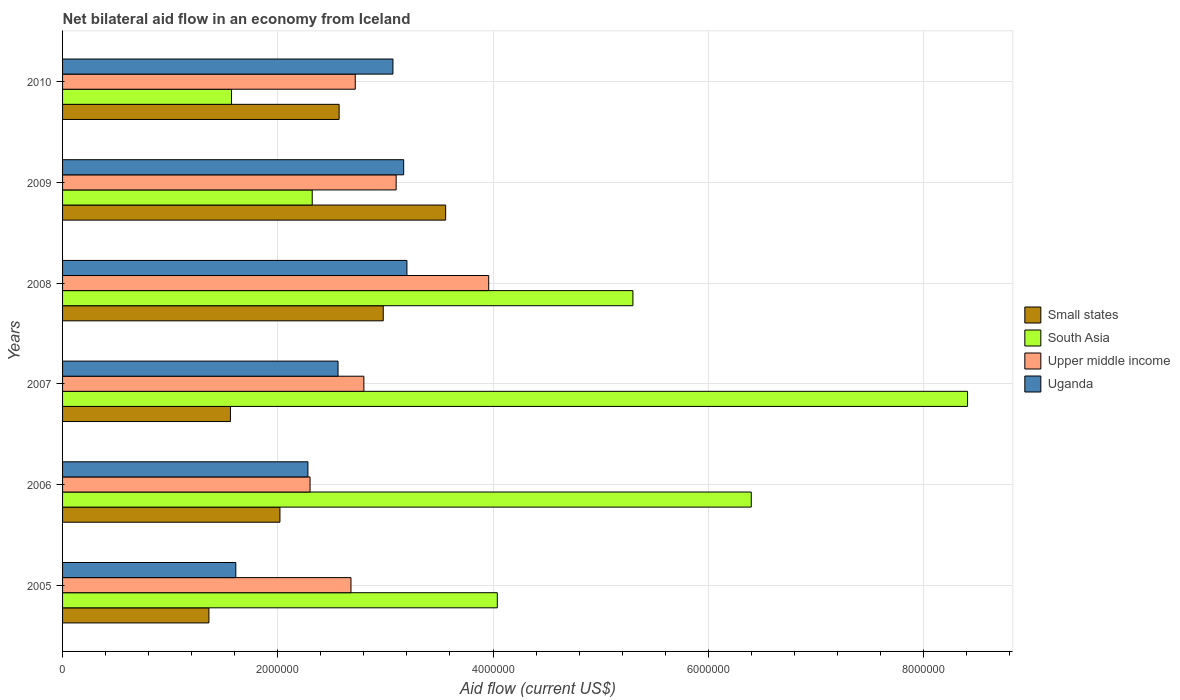How many groups of bars are there?
Offer a very short reply. 6. How many bars are there on the 4th tick from the top?
Make the answer very short. 4. How many bars are there on the 5th tick from the bottom?
Your answer should be compact. 4. What is the label of the 5th group of bars from the top?
Provide a short and direct response. 2006. In how many cases, is the number of bars for a given year not equal to the number of legend labels?
Make the answer very short. 0. What is the net bilateral aid flow in Upper middle income in 2010?
Offer a very short reply. 2.72e+06. Across all years, what is the maximum net bilateral aid flow in Uganda?
Provide a succinct answer. 3.20e+06. Across all years, what is the minimum net bilateral aid flow in Uganda?
Give a very brief answer. 1.61e+06. In which year was the net bilateral aid flow in Uganda maximum?
Make the answer very short. 2008. What is the total net bilateral aid flow in Upper middle income in the graph?
Provide a succinct answer. 1.76e+07. What is the difference between the net bilateral aid flow in South Asia in 2005 and that in 2009?
Provide a succinct answer. 1.72e+06. What is the difference between the net bilateral aid flow in South Asia in 2006 and the net bilateral aid flow in Upper middle income in 2007?
Your response must be concise. 3.60e+06. What is the average net bilateral aid flow in South Asia per year?
Keep it short and to the point. 4.67e+06. In the year 2007, what is the difference between the net bilateral aid flow in Small states and net bilateral aid flow in Upper middle income?
Your answer should be very brief. -1.24e+06. What is the ratio of the net bilateral aid flow in Small states in 2005 to that in 2008?
Ensure brevity in your answer.  0.46. Is the difference between the net bilateral aid flow in Small states in 2008 and 2009 greater than the difference between the net bilateral aid flow in Upper middle income in 2008 and 2009?
Your response must be concise. No. What is the difference between the highest and the second highest net bilateral aid flow in South Asia?
Keep it short and to the point. 2.01e+06. What is the difference between the highest and the lowest net bilateral aid flow in South Asia?
Make the answer very short. 6.84e+06. What does the 1st bar from the top in 2008 represents?
Offer a very short reply. Uganda. Is it the case that in every year, the sum of the net bilateral aid flow in South Asia and net bilateral aid flow in Upper middle income is greater than the net bilateral aid flow in Uganda?
Give a very brief answer. Yes. How many bars are there?
Offer a terse response. 24. How many years are there in the graph?
Provide a short and direct response. 6. What is the difference between two consecutive major ticks on the X-axis?
Keep it short and to the point. 2.00e+06. Where does the legend appear in the graph?
Keep it short and to the point. Center right. How many legend labels are there?
Your response must be concise. 4. How are the legend labels stacked?
Your answer should be very brief. Vertical. What is the title of the graph?
Give a very brief answer. Net bilateral aid flow in an economy from Iceland. What is the label or title of the X-axis?
Offer a terse response. Aid flow (current US$). What is the label or title of the Y-axis?
Provide a succinct answer. Years. What is the Aid flow (current US$) of Small states in 2005?
Make the answer very short. 1.36e+06. What is the Aid flow (current US$) of South Asia in 2005?
Your answer should be very brief. 4.04e+06. What is the Aid flow (current US$) of Upper middle income in 2005?
Provide a short and direct response. 2.68e+06. What is the Aid flow (current US$) in Uganda in 2005?
Keep it short and to the point. 1.61e+06. What is the Aid flow (current US$) of Small states in 2006?
Offer a terse response. 2.02e+06. What is the Aid flow (current US$) of South Asia in 2006?
Offer a terse response. 6.40e+06. What is the Aid flow (current US$) in Upper middle income in 2006?
Your answer should be compact. 2.30e+06. What is the Aid flow (current US$) of Uganda in 2006?
Your answer should be compact. 2.28e+06. What is the Aid flow (current US$) of Small states in 2007?
Your answer should be very brief. 1.56e+06. What is the Aid flow (current US$) of South Asia in 2007?
Your answer should be very brief. 8.41e+06. What is the Aid flow (current US$) in Upper middle income in 2007?
Offer a very short reply. 2.80e+06. What is the Aid flow (current US$) in Uganda in 2007?
Make the answer very short. 2.56e+06. What is the Aid flow (current US$) in Small states in 2008?
Provide a succinct answer. 2.98e+06. What is the Aid flow (current US$) of South Asia in 2008?
Your answer should be compact. 5.30e+06. What is the Aid flow (current US$) of Upper middle income in 2008?
Offer a terse response. 3.96e+06. What is the Aid flow (current US$) of Uganda in 2008?
Offer a terse response. 3.20e+06. What is the Aid flow (current US$) in Small states in 2009?
Your answer should be compact. 3.56e+06. What is the Aid flow (current US$) of South Asia in 2009?
Give a very brief answer. 2.32e+06. What is the Aid flow (current US$) in Upper middle income in 2009?
Your answer should be compact. 3.10e+06. What is the Aid flow (current US$) of Uganda in 2009?
Your answer should be very brief. 3.17e+06. What is the Aid flow (current US$) in Small states in 2010?
Offer a very short reply. 2.57e+06. What is the Aid flow (current US$) of South Asia in 2010?
Provide a short and direct response. 1.57e+06. What is the Aid flow (current US$) of Upper middle income in 2010?
Provide a short and direct response. 2.72e+06. What is the Aid flow (current US$) of Uganda in 2010?
Make the answer very short. 3.07e+06. Across all years, what is the maximum Aid flow (current US$) in Small states?
Provide a succinct answer. 3.56e+06. Across all years, what is the maximum Aid flow (current US$) in South Asia?
Make the answer very short. 8.41e+06. Across all years, what is the maximum Aid flow (current US$) of Upper middle income?
Ensure brevity in your answer.  3.96e+06. Across all years, what is the maximum Aid flow (current US$) of Uganda?
Give a very brief answer. 3.20e+06. Across all years, what is the minimum Aid flow (current US$) in Small states?
Your response must be concise. 1.36e+06. Across all years, what is the minimum Aid flow (current US$) in South Asia?
Your answer should be compact. 1.57e+06. Across all years, what is the minimum Aid flow (current US$) of Upper middle income?
Make the answer very short. 2.30e+06. Across all years, what is the minimum Aid flow (current US$) in Uganda?
Your response must be concise. 1.61e+06. What is the total Aid flow (current US$) in Small states in the graph?
Ensure brevity in your answer.  1.40e+07. What is the total Aid flow (current US$) in South Asia in the graph?
Provide a succinct answer. 2.80e+07. What is the total Aid flow (current US$) of Upper middle income in the graph?
Ensure brevity in your answer.  1.76e+07. What is the total Aid flow (current US$) in Uganda in the graph?
Give a very brief answer. 1.59e+07. What is the difference between the Aid flow (current US$) in Small states in 2005 and that in 2006?
Offer a terse response. -6.60e+05. What is the difference between the Aid flow (current US$) in South Asia in 2005 and that in 2006?
Ensure brevity in your answer.  -2.36e+06. What is the difference between the Aid flow (current US$) in Upper middle income in 2005 and that in 2006?
Your answer should be compact. 3.80e+05. What is the difference between the Aid flow (current US$) in Uganda in 2005 and that in 2006?
Offer a very short reply. -6.70e+05. What is the difference between the Aid flow (current US$) of South Asia in 2005 and that in 2007?
Keep it short and to the point. -4.37e+06. What is the difference between the Aid flow (current US$) of Uganda in 2005 and that in 2007?
Make the answer very short. -9.50e+05. What is the difference between the Aid flow (current US$) of Small states in 2005 and that in 2008?
Ensure brevity in your answer.  -1.62e+06. What is the difference between the Aid flow (current US$) in South Asia in 2005 and that in 2008?
Keep it short and to the point. -1.26e+06. What is the difference between the Aid flow (current US$) of Upper middle income in 2005 and that in 2008?
Offer a very short reply. -1.28e+06. What is the difference between the Aid flow (current US$) in Uganda in 2005 and that in 2008?
Ensure brevity in your answer.  -1.59e+06. What is the difference between the Aid flow (current US$) in Small states in 2005 and that in 2009?
Keep it short and to the point. -2.20e+06. What is the difference between the Aid flow (current US$) of South Asia in 2005 and that in 2009?
Provide a short and direct response. 1.72e+06. What is the difference between the Aid flow (current US$) in Upper middle income in 2005 and that in 2009?
Ensure brevity in your answer.  -4.20e+05. What is the difference between the Aid flow (current US$) in Uganda in 2005 and that in 2009?
Your answer should be very brief. -1.56e+06. What is the difference between the Aid flow (current US$) of Small states in 2005 and that in 2010?
Keep it short and to the point. -1.21e+06. What is the difference between the Aid flow (current US$) in South Asia in 2005 and that in 2010?
Your answer should be compact. 2.47e+06. What is the difference between the Aid flow (current US$) in Uganda in 2005 and that in 2010?
Make the answer very short. -1.46e+06. What is the difference between the Aid flow (current US$) of Small states in 2006 and that in 2007?
Give a very brief answer. 4.60e+05. What is the difference between the Aid flow (current US$) in South Asia in 2006 and that in 2007?
Offer a very short reply. -2.01e+06. What is the difference between the Aid flow (current US$) of Upper middle income in 2006 and that in 2007?
Your response must be concise. -5.00e+05. What is the difference between the Aid flow (current US$) of Uganda in 2006 and that in 2007?
Keep it short and to the point. -2.80e+05. What is the difference between the Aid flow (current US$) in Small states in 2006 and that in 2008?
Your response must be concise. -9.60e+05. What is the difference between the Aid flow (current US$) in South Asia in 2006 and that in 2008?
Your answer should be compact. 1.10e+06. What is the difference between the Aid flow (current US$) in Upper middle income in 2006 and that in 2008?
Your answer should be very brief. -1.66e+06. What is the difference between the Aid flow (current US$) in Uganda in 2006 and that in 2008?
Provide a succinct answer. -9.20e+05. What is the difference between the Aid flow (current US$) in Small states in 2006 and that in 2009?
Your answer should be very brief. -1.54e+06. What is the difference between the Aid flow (current US$) in South Asia in 2006 and that in 2009?
Provide a short and direct response. 4.08e+06. What is the difference between the Aid flow (current US$) of Upper middle income in 2006 and that in 2009?
Offer a very short reply. -8.00e+05. What is the difference between the Aid flow (current US$) of Uganda in 2006 and that in 2009?
Your answer should be compact. -8.90e+05. What is the difference between the Aid flow (current US$) of Small states in 2006 and that in 2010?
Provide a short and direct response. -5.50e+05. What is the difference between the Aid flow (current US$) in South Asia in 2006 and that in 2010?
Your response must be concise. 4.83e+06. What is the difference between the Aid flow (current US$) of Upper middle income in 2006 and that in 2010?
Provide a succinct answer. -4.20e+05. What is the difference between the Aid flow (current US$) of Uganda in 2006 and that in 2010?
Provide a succinct answer. -7.90e+05. What is the difference between the Aid flow (current US$) in Small states in 2007 and that in 2008?
Ensure brevity in your answer.  -1.42e+06. What is the difference between the Aid flow (current US$) of South Asia in 2007 and that in 2008?
Your answer should be compact. 3.11e+06. What is the difference between the Aid flow (current US$) in Upper middle income in 2007 and that in 2008?
Your answer should be compact. -1.16e+06. What is the difference between the Aid flow (current US$) in Uganda in 2007 and that in 2008?
Give a very brief answer. -6.40e+05. What is the difference between the Aid flow (current US$) in South Asia in 2007 and that in 2009?
Your answer should be compact. 6.09e+06. What is the difference between the Aid flow (current US$) in Upper middle income in 2007 and that in 2009?
Your answer should be compact. -3.00e+05. What is the difference between the Aid flow (current US$) in Uganda in 2007 and that in 2009?
Keep it short and to the point. -6.10e+05. What is the difference between the Aid flow (current US$) of Small states in 2007 and that in 2010?
Ensure brevity in your answer.  -1.01e+06. What is the difference between the Aid flow (current US$) in South Asia in 2007 and that in 2010?
Ensure brevity in your answer.  6.84e+06. What is the difference between the Aid flow (current US$) in Upper middle income in 2007 and that in 2010?
Offer a terse response. 8.00e+04. What is the difference between the Aid flow (current US$) in Uganda in 2007 and that in 2010?
Make the answer very short. -5.10e+05. What is the difference between the Aid flow (current US$) in Small states in 2008 and that in 2009?
Give a very brief answer. -5.80e+05. What is the difference between the Aid flow (current US$) of South Asia in 2008 and that in 2009?
Your answer should be compact. 2.98e+06. What is the difference between the Aid flow (current US$) in Upper middle income in 2008 and that in 2009?
Give a very brief answer. 8.60e+05. What is the difference between the Aid flow (current US$) in Small states in 2008 and that in 2010?
Offer a terse response. 4.10e+05. What is the difference between the Aid flow (current US$) of South Asia in 2008 and that in 2010?
Offer a terse response. 3.73e+06. What is the difference between the Aid flow (current US$) in Upper middle income in 2008 and that in 2010?
Make the answer very short. 1.24e+06. What is the difference between the Aid flow (current US$) in Small states in 2009 and that in 2010?
Provide a short and direct response. 9.90e+05. What is the difference between the Aid flow (current US$) in South Asia in 2009 and that in 2010?
Offer a very short reply. 7.50e+05. What is the difference between the Aid flow (current US$) of Small states in 2005 and the Aid flow (current US$) of South Asia in 2006?
Give a very brief answer. -5.04e+06. What is the difference between the Aid flow (current US$) in Small states in 2005 and the Aid flow (current US$) in Upper middle income in 2006?
Keep it short and to the point. -9.40e+05. What is the difference between the Aid flow (current US$) of Small states in 2005 and the Aid flow (current US$) of Uganda in 2006?
Your response must be concise. -9.20e+05. What is the difference between the Aid flow (current US$) of South Asia in 2005 and the Aid flow (current US$) of Upper middle income in 2006?
Your answer should be compact. 1.74e+06. What is the difference between the Aid flow (current US$) of South Asia in 2005 and the Aid flow (current US$) of Uganda in 2006?
Give a very brief answer. 1.76e+06. What is the difference between the Aid flow (current US$) in Upper middle income in 2005 and the Aid flow (current US$) in Uganda in 2006?
Make the answer very short. 4.00e+05. What is the difference between the Aid flow (current US$) in Small states in 2005 and the Aid flow (current US$) in South Asia in 2007?
Ensure brevity in your answer.  -7.05e+06. What is the difference between the Aid flow (current US$) in Small states in 2005 and the Aid flow (current US$) in Upper middle income in 2007?
Make the answer very short. -1.44e+06. What is the difference between the Aid flow (current US$) of Small states in 2005 and the Aid flow (current US$) of Uganda in 2007?
Your answer should be compact. -1.20e+06. What is the difference between the Aid flow (current US$) of South Asia in 2005 and the Aid flow (current US$) of Upper middle income in 2007?
Keep it short and to the point. 1.24e+06. What is the difference between the Aid flow (current US$) in South Asia in 2005 and the Aid flow (current US$) in Uganda in 2007?
Ensure brevity in your answer.  1.48e+06. What is the difference between the Aid flow (current US$) in Upper middle income in 2005 and the Aid flow (current US$) in Uganda in 2007?
Your answer should be very brief. 1.20e+05. What is the difference between the Aid flow (current US$) in Small states in 2005 and the Aid flow (current US$) in South Asia in 2008?
Your response must be concise. -3.94e+06. What is the difference between the Aid flow (current US$) of Small states in 2005 and the Aid flow (current US$) of Upper middle income in 2008?
Ensure brevity in your answer.  -2.60e+06. What is the difference between the Aid flow (current US$) of Small states in 2005 and the Aid flow (current US$) of Uganda in 2008?
Make the answer very short. -1.84e+06. What is the difference between the Aid flow (current US$) in South Asia in 2005 and the Aid flow (current US$) in Uganda in 2008?
Your response must be concise. 8.40e+05. What is the difference between the Aid flow (current US$) of Upper middle income in 2005 and the Aid flow (current US$) of Uganda in 2008?
Your response must be concise. -5.20e+05. What is the difference between the Aid flow (current US$) in Small states in 2005 and the Aid flow (current US$) in South Asia in 2009?
Provide a short and direct response. -9.60e+05. What is the difference between the Aid flow (current US$) of Small states in 2005 and the Aid flow (current US$) of Upper middle income in 2009?
Make the answer very short. -1.74e+06. What is the difference between the Aid flow (current US$) of Small states in 2005 and the Aid flow (current US$) of Uganda in 2009?
Provide a short and direct response. -1.81e+06. What is the difference between the Aid flow (current US$) in South Asia in 2005 and the Aid flow (current US$) in Upper middle income in 2009?
Your answer should be very brief. 9.40e+05. What is the difference between the Aid flow (current US$) of South Asia in 2005 and the Aid flow (current US$) of Uganda in 2009?
Ensure brevity in your answer.  8.70e+05. What is the difference between the Aid flow (current US$) of Upper middle income in 2005 and the Aid flow (current US$) of Uganda in 2009?
Ensure brevity in your answer.  -4.90e+05. What is the difference between the Aid flow (current US$) of Small states in 2005 and the Aid flow (current US$) of Upper middle income in 2010?
Your response must be concise. -1.36e+06. What is the difference between the Aid flow (current US$) of Small states in 2005 and the Aid flow (current US$) of Uganda in 2010?
Give a very brief answer. -1.71e+06. What is the difference between the Aid flow (current US$) of South Asia in 2005 and the Aid flow (current US$) of Upper middle income in 2010?
Offer a very short reply. 1.32e+06. What is the difference between the Aid flow (current US$) of South Asia in 2005 and the Aid flow (current US$) of Uganda in 2010?
Give a very brief answer. 9.70e+05. What is the difference between the Aid flow (current US$) in Upper middle income in 2005 and the Aid flow (current US$) in Uganda in 2010?
Offer a very short reply. -3.90e+05. What is the difference between the Aid flow (current US$) of Small states in 2006 and the Aid flow (current US$) of South Asia in 2007?
Offer a terse response. -6.39e+06. What is the difference between the Aid flow (current US$) of Small states in 2006 and the Aid flow (current US$) of Upper middle income in 2007?
Provide a succinct answer. -7.80e+05. What is the difference between the Aid flow (current US$) in Small states in 2006 and the Aid flow (current US$) in Uganda in 2007?
Your response must be concise. -5.40e+05. What is the difference between the Aid flow (current US$) of South Asia in 2006 and the Aid flow (current US$) of Upper middle income in 2007?
Your response must be concise. 3.60e+06. What is the difference between the Aid flow (current US$) in South Asia in 2006 and the Aid flow (current US$) in Uganda in 2007?
Provide a short and direct response. 3.84e+06. What is the difference between the Aid flow (current US$) in Small states in 2006 and the Aid flow (current US$) in South Asia in 2008?
Your answer should be very brief. -3.28e+06. What is the difference between the Aid flow (current US$) in Small states in 2006 and the Aid flow (current US$) in Upper middle income in 2008?
Ensure brevity in your answer.  -1.94e+06. What is the difference between the Aid flow (current US$) of Small states in 2006 and the Aid flow (current US$) of Uganda in 2008?
Ensure brevity in your answer.  -1.18e+06. What is the difference between the Aid flow (current US$) of South Asia in 2006 and the Aid flow (current US$) of Upper middle income in 2008?
Provide a succinct answer. 2.44e+06. What is the difference between the Aid flow (current US$) of South Asia in 2006 and the Aid flow (current US$) of Uganda in 2008?
Offer a terse response. 3.20e+06. What is the difference between the Aid flow (current US$) in Upper middle income in 2006 and the Aid flow (current US$) in Uganda in 2008?
Your response must be concise. -9.00e+05. What is the difference between the Aid flow (current US$) in Small states in 2006 and the Aid flow (current US$) in Upper middle income in 2009?
Your answer should be compact. -1.08e+06. What is the difference between the Aid flow (current US$) of Small states in 2006 and the Aid flow (current US$) of Uganda in 2009?
Give a very brief answer. -1.15e+06. What is the difference between the Aid flow (current US$) of South Asia in 2006 and the Aid flow (current US$) of Upper middle income in 2009?
Your answer should be compact. 3.30e+06. What is the difference between the Aid flow (current US$) in South Asia in 2006 and the Aid flow (current US$) in Uganda in 2009?
Give a very brief answer. 3.23e+06. What is the difference between the Aid flow (current US$) in Upper middle income in 2006 and the Aid flow (current US$) in Uganda in 2009?
Ensure brevity in your answer.  -8.70e+05. What is the difference between the Aid flow (current US$) of Small states in 2006 and the Aid flow (current US$) of Upper middle income in 2010?
Ensure brevity in your answer.  -7.00e+05. What is the difference between the Aid flow (current US$) of Small states in 2006 and the Aid flow (current US$) of Uganda in 2010?
Provide a short and direct response. -1.05e+06. What is the difference between the Aid flow (current US$) in South Asia in 2006 and the Aid flow (current US$) in Upper middle income in 2010?
Offer a terse response. 3.68e+06. What is the difference between the Aid flow (current US$) of South Asia in 2006 and the Aid flow (current US$) of Uganda in 2010?
Give a very brief answer. 3.33e+06. What is the difference between the Aid flow (current US$) of Upper middle income in 2006 and the Aid flow (current US$) of Uganda in 2010?
Make the answer very short. -7.70e+05. What is the difference between the Aid flow (current US$) of Small states in 2007 and the Aid flow (current US$) of South Asia in 2008?
Provide a succinct answer. -3.74e+06. What is the difference between the Aid flow (current US$) of Small states in 2007 and the Aid flow (current US$) of Upper middle income in 2008?
Make the answer very short. -2.40e+06. What is the difference between the Aid flow (current US$) in Small states in 2007 and the Aid flow (current US$) in Uganda in 2008?
Make the answer very short. -1.64e+06. What is the difference between the Aid flow (current US$) of South Asia in 2007 and the Aid flow (current US$) of Upper middle income in 2008?
Provide a short and direct response. 4.45e+06. What is the difference between the Aid flow (current US$) of South Asia in 2007 and the Aid flow (current US$) of Uganda in 2008?
Your answer should be very brief. 5.21e+06. What is the difference between the Aid flow (current US$) of Upper middle income in 2007 and the Aid flow (current US$) of Uganda in 2008?
Your answer should be very brief. -4.00e+05. What is the difference between the Aid flow (current US$) in Small states in 2007 and the Aid flow (current US$) in South Asia in 2009?
Give a very brief answer. -7.60e+05. What is the difference between the Aid flow (current US$) of Small states in 2007 and the Aid flow (current US$) of Upper middle income in 2009?
Give a very brief answer. -1.54e+06. What is the difference between the Aid flow (current US$) in Small states in 2007 and the Aid flow (current US$) in Uganda in 2009?
Give a very brief answer. -1.61e+06. What is the difference between the Aid flow (current US$) in South Asia in 2007 and the Aid flow (current US$) in Upper middle income in 2009?
Ensure brevity in your answer.  5.31e+06. What is the difference between the Aid flow (current US$) in South Asia in 2007 and the Aid flow (current US$) in Uganda in 2009?
Provide a succinct answer. 5.24e+06. What is the difference between the Aid flow (current US$) of Upper middle income in 2007 and the Aid flow (current US$) of Uganda in 2009?
Give a very brief answer. -3.70e+05. What is the difference between the Aid flow (current US$) in Small states in 2007 and the Aid flow (current US$) in Upper middle income in 2010?
Keep it short and to the point. -1.16e+06. What is the difference between the Aid flow (current US$) in Small states in 2007 and the Aid flow (current US$) in Uganda in 2010?
Give a very brief answer. -1.51e+06. What is the difference between the Aid flow (current US$) in South Asia in 2007 and the Aid flow (current US$) in Upper middle income in 2010?
Keep it short and to the point. 5.69e+06. What is the difference between the Aid flow (current US$) in South Asia in 2007 and the Aid flow (current US$) in Uganda in 2010?
Your answer should be compact. 5.34e+06. What is the difference between the Aid flow (current US$) in Upper middle income in 2007 and the Aid flow (current US$) in Uganda in 2010?
Ensure brevity in your answer.  -2.70e+05. What is the difference between the Aid flow (current US$) in Small states in 2008 and the Aid flow (current US$) in South Asia in 2009?
Your response must be concise. 6.60e+05. What is the difference between the Aid flow (current US$) of Small states in 2008 and the Aid flow (current US$) of Upper middle income in 2009?
Your response must be concise. -1.20e+05. What is the difference between the Aid flow (current US$) in South Asia in 2008 and the Aid flow (current US$) in Upper middle income in 2009?
Offer a terse response. 2.20e+06. What is the difference between the Aid flow (current US$) in South Asia in 2008 and the Aid flow (current US$) in Uganda in 2009?
Ensure brevity in your answer.  2.13e+06. What is the difference between the Aid flow (current US$) of Upper middle income in 2008 and the Aid flow (current US$) of Uganda in 2009?
Offer a very short reply. 7.90e+05. What is the difference between the Aid flow (current US$) of Small states in 2008 and the Aid flow (current US$) of South Asia in 2010?
Give a very brief answer. 1.41e+06. What is the difference between the Aid flow (current US$) of Small states in 2008 and the Aid flow (current US$) of Uganda in 2010?
Offer a terse response. -9.00e+04. What is the difference between the Aid flow (current US$) in South Asia in 2008 and the Aid flow (current US$) in Upper middle income in 2010?
Provide a succinct answer. 2.58e+06. What is the difference between the Aid flow (current US$) of South Asia in 2008 and the Aid flow (current US$) of Uganda in 2010?
Your response must be concise. 2.23e+06. What is the difference between the Aid flow (current US$) in Upper middle income in 2008 and the Aid flow (current US$) in Uganda in 2010?
Offer a terse response. 8.90e+05. What is the difference between the Aid flow (current US$) in Small states in 2009 and the Aid flow (current US$) in South Asia in 2010?
Provide a short and direct response. 1.99e+06. What is the difference between the Aid flow (current US$) in Small states in 2009 and the Aid flow (current US$) in Upper middle income in 2010?
Keep it short and to the point. 8.40e+05. What is the difference between the Aid flow (current US$) of Small states in 2009 and the Aid flow (current US$) of Uganda in 2010?
Give a very brief answer. 4.90e+05. What is the difference between the Aid flow (current US$) in South Asia in 2009 and the Aid flow (current US$) in Upper middle income in 2010?
Your answer should be compact. -4.00e+05. What is the difference between the Aid flow (current US$) in South Asia in 2009 and the Aid flow (current US$) in Uganda in 2010?
Ensure brevity in your answer.  -7.50e+05. What is the average Aid flow (current US$) in Small states per year?
Make the answer very short. 2.34e+06. What is the average Aid flow (current US$) in South Asia per year?
Offer a terse response. 4.67e+06. What is the average Aid flow (current US$) in Upper middle income per year?
Keep it short and to the point. 2.93e+06. What is the average Aid flow (current US$) in Uganda per year?
Give a very brief answer. 2.65e+06. In the year 2005, what is the difference between the Aid flow (current US$) in Small states and Aid flow (current US$) in South Asia?
Provide a short and direct response. -2.68e+06. In the year 2005, what is the difference between the Aid flow (current US$) in Small states and Aid flow (current US$) in Upper middle income?
Your answer should be very brief. -1.32e+06. In the year 2005, what is the difference between the Aid flow (current US$) of Small states and Aid flow (current US$) of Uganda?
Your response must be concise. -2.50e+05. In the year 2005, what is the difference between the Aid flow (current US$) in South Asia and Aid flow (current US$) in Upper middle income?
Provide a succinct answer. 1.36e+06. In the year 2005, what is the difference between the Aid flow (current US$) in South Asia and Aid flow (current US$) in Uganda?
Offer a very short reply. 2.43e+06. In the year 2005, what is the difference between the Aid flow (current US$) in Upper middle income and Aid flow (current US$) in Uganda?
Provide a short and direct response. 1.07e+06. In the year 2006, what is the difference between the Aid flow (current US$) of Small states and Aid flow (current US$) of South Asia?
Offer a very short reply. -4.38e+06. In the year 2006, what is the difference between the Aid flow (current US$) of Small states and Aid flow (current US$) of Upper middle income?
Make the answer very short. -2.80e+05. In the year 2006, what is the difference between the Aid flow (current US$) of Small states and Aid flow (current US$) of Uganda?
Give a very brief answer. -2.60e+05. In the year 2006, what is the difference between the Aid flow (current US$) of South Asia and Aid flow (current US$) of Upper middle income?
Your answer should be compact. 4.10e+06. In the year 2006, what is the difference between the Aid flow (current US$) in South Asia and Aid flow (current US$) in Uganda?
Provide a short and direct response. 4.12e+06. In the year 2006, what is the difference between the Aid flow (current US$) in Upper middle income and Aid flow (current US$) in Uganda?
Your answer should be very brief. 2.00e+04. In the year 2007, what is the difference between the Aid flow (current US$) of Small states and Aid flow (current US$) of South Asia?
Provide a succinct answer. -6.85e+06. In the year 2007, what is the difference between the Aid flow (current US$) of Small states and Aid flow (current US$) of Upper middle income?
Make the answer very short. -1.24e+06. In the year 2007, what is the difference between the Aid flow (current US$) of Small states and Aid flow (current US$) of Uganda?
Provide a succinct answer. -1.00e+06. In the year 2007, what is the difference between the Aid flow (current US$) of South Asia and Aid flow (current US$) of Upper middle income?
Your answer should be compact. 5.61e+06. In the year 2007, what is the difference between the Aid flow (current US$) of South Asia and Aid flow (current US$) of Uganda?
Ensure brevity in your answer.  5.85e+06. In the year 2007, what is the difference between the Aid flow (current US$) in Upper middle income and Aid flow (current US$) in Uganda?
Provide a succinct answer. 2.40e+05. In the year 2008, what is the difference between the Aid flow (current US$) in Small states and Aid flow (current US$) in South Asia?
Your answer should be very brief. -2.32e+06. In the year 2008, what is the difference between the Aid flow (current US$) of Small states and Aid flow (current US$) of Upper middle income?
Provide a short and direct response. -9.80e+05. In the year 2008, what is the difference between the Aid flow (current US$) of Small states and Aid flow (current US$) of Uganda?
Ensure brevity in your answer.  -2.20e+05. In the year 2008, what is the difference between the Aid flow (current US$) of South Asia and Aid flow (current US$) of Upper middle income?
Give a very brief answer. 1.34e+06. In the year 2008, what is the difference between the Aid flow (current US$) of South Asia and Aid flow (current US$) of Uganda?
Provide a short and direct response. 2.10e+06. In the year 2008, what is the difference between the Aid flow (current US$) of Upper middle income and Aid flow (current US$) of Uganda?
Make the answer very short. 7.60e+05. In the year 2009, what is the difference between the Aid flow (current US$) of Small states and Aid flow (current US$) of South Asia?
Offer a terse response. 1.24e+06. In the year 2009, what is the difference between the Aid flow (current US$) of Small states and Aid flow (current US$) of Upper middle income?
Offer a very short reply. 4.60e+05. In the year 2009, what is the difference between the Aid flow (current US$) in Small states and Aid flow (current US$) in Uganda?
Provide a succinct answer. 3.90e+05. In the year 2009, what is the difference between the Aid flow (current US$) of South Asia and Aid flow (current US$) of Upper middle income?
Provide a short and direct response. -7.80e+05. In the year 2009, what is the difference between the Aid flow (current US$) in South Asia and Aid flow (current US$) in Uganda?
Your answer should be very brief. -8.50e+05. In the year 2010, what is the difference between the Aid flow (current US$) in Small states and Aid flow (current US$) in South Asia?
Give a very brief answer. 1.00e+06. In the year 2010, what is the difference between the Aid flow (current US$) in Small states and Aid flow (current US$) in Upper middle income?
Offer a terse response. -1.50e+05. In the year 2010, what is the difference between the Aid flow (current US$) in Small states and Aid flow (current US$) in Uganda?
Your answer should be compact. -5.00e+05. In the year 2010, what is the difference between the Aid flow (current US$) in South Asia and Aid flow (current US$) in Upper middle income?
Provide a short and direct response. -1.15e+06. In the year 2010, what is the difference between the Aid flow (current US$) of South Asia and Aid flow (current US$) of Uganda?
Provide a succinct answer. -1.50e+06. In the year 2010, what is the difference between the Aid flow (current US$) in Upper middle income and Aid flow (current US$) in Uganda?
Your answer should be compact. -3.50e+05. What is the ratio of the Aid flow (current US$) in Small states in 2005 to that in 2006?
Keep it short and to the point. 0.67. What is the ratio of the Aid flow (current US$) in South Asia in 2005 to that in 2006?
Your response must be concise. 0.63. What is the ratio of the Aid flow (current US$) in Upper middle income in 2005 to that in 2006?
Make the answer very short. 1.17. What is the ratio of the Aid flow (current US$) of Uganda in 2005 to that in 2006?
Your response must be concise. 0.71. What is the ratio of the Aid flow (current US$) of Small states in 2005 to that in 2007?
Give a very brief answer. 0.87. What is the ratio of the Aid flow (current US$) of South Asia in 2005 to that in 2007?
Your answer should be compact. 0.48. What is the ratio of the Aid flow (current US$) in Upper middle income in 2005 to that in 2007?
Provide a short and direct response. 0.96. What is the ratio of the Aid flow (current US$) of Uganda in 2005 to that in 2007?
Keep it short and to the point. 0.63. What is the ratio of the Aid flow (current US$) in Small states in 2005 to that in 2008?
Keep it short and to the point. 0.46. What is the ratio of the Aid flow (current US$) of South Asia in 2005 to that in 2008?
Your answer should be very brief. 0.76. What is the ratio of the Aid flow (current US$) in Upper middle income in 2005 to that in 2008?
Keep it short and to the point. 0.68. What is the ratio of the Aid flow (current US$) in Uganda in 2005 to that in 2008?
Offer a terse response. 0.5. What is the ratio of the Aid flow (current US$) of Small states in 2005 to that in 2009?
Offer a very short reply. 0.38. What is the ratio of the Aid flow (current US$) of South Asia in 2005 to that in 2009?
Ensure brevity in your answer.  1.74. What is the ratio of the Aid flow (current US$) in Upper middle income in 2005 to that in 2009?
Ensure brevity in your answer.  0.86. What is the ratio of the Aid flow (current US$) of Uganda in 2005 to that in 2009?
Give a very brief answer. 0.51. What is the ratio of the Aid flow (current US$) in Small states in 2005 to that in 2010?
Your answer should be very brief. 0.53. What is the ratio of the Aid flow (current US$) of South Asia in 2005 to that in 2010?
Provide a short and direct response. 2.57. What is the ratio of the Aid flow (current US$) in Upper middle income in 2005 to that in 2010?
Your response must be concise. 0.99. What is the ratio of the Aid flow (current US$) of Uganda in 2005 to that in 2010?
Provide a succinct answer. 0.52. What is the ratio of the Aid flow (current US$) of Small states in 2006 to that in 2007?
Ensure brevity in your answer.  1.29. What is the ratio of the Aid flow (current US$) of South Asia in 2006 to that in 2007?
Provide a succinct answer. 0.76. What is the ratio of the Aid flow (current US$) of Upper middle income in 2006 to that in 2007?
Give a very brief answer. 0.82. What is the ratio of the Aid flow (current US$) of Uganda in 2006 to that in 2007?
Give a very brief answer. 0.89. What is the ratio of the Aid flow (current US$) of Small states in 2006 to that in 2008?
Provide a succinct answer. 0.68. What is the ratio of the Aid flow (current US$) in South Asia in 2006 to that in 2008?
Give a very brief answer. 1.21. What is the ratio of the Aid flow (current US$) of Upper middle income in 2006 to that in 2008?
Keep it short and to the point. 0.58. What is the ratio of the Aid flow (current US$) in Uganda in 2006 to that in 2008?
Ensure brevity in your answer.  0.71. What is the ratio of the Aid flow (current US$) of Small states in 2006 to that in 2009?
Provide a short and direct response. 0.57. What is the ratio of the Aid flow (current US$) of South Asia in 2006 to that in 2009?
Offer a very short reply. 2.76. What is the ratio of the Aid flow (current US$) of Upper middle income in 2006 to that in 2009?
Offer a terse response. 0.74. What is the ratio of the Aid flow (current US$) in Uganda in 2006 to that in 2009?
Provide a short and direct response. 0.72. What is the ratio of the Aid flow (current US$) of Small states in 2006 to that in 2010?
Your response must be concise. 0.79. What is the ratio of the Aid flow (current US$) of South Asia in 2006 to that in 2010?
Offer a very short reply. 4.08. What is the ratio of the Aid flow (current US$) of Upper middle income in 2006 to that in 2010?
Give a very brief answer. 0.85. What is the ratio of the Aid flow (current US$) in Uganda in 2006 to that in 2010?
Ensure brevity in your answer.  0.74. What is the ratio of the Aid flow (current US$) in Small states in 2007 to that in 2008?
Keep it short and to the point. 0.52. What is the ratio of the Aid flow (current US$) in South Asia in 2007 to that in 2008?
Your response must be concise. 1.59. What is the ratio of the Aid flow (current US$) in Upper middle income in 2007 to that in 2008?
Make the answer very short. 0.71. What is the ratio of the Aid flow (current US$) of Small states in 2007 to that in 2009?
Provide a short and direct response. 0.44. What is the ratio of the Aid flow (current US$) of South Asia in 2007 to that in 2009?
Provide a short and direct response. 3.62. What is the ratio of the Aid flow (current US$) of Upper middle income in 2007 to that in 2009?
Offer a very short reply. 0.9. What is the ratio of the Aid flow (current US$) of Uganda in 2007 to that in 2009?
Ensure brevity in your answer.  0.81. What is the ratio of the Aid flow (current US$) of Small states in 2007 to that in 2010?
Your answer should be very brief. 0.61. What is the ratio of the Aid flow (current US$) of South Asia in 2007 to that in 2010?
Provide a short and direct response. 5.36. What is the ratio of the Aid flow (current US$) in Upper middle income in 2007 to that in 2010?
Your answer should be very brief. 1.03. What is the ratio of the Aid flow (current US$) of Uganda in 2007 to that in 2010?
Offer a terse response. 0.83. What is the ratio of the Aid flow (current US$) in Small states in 2008 to that in 2009?
Your answer should be very brief. 0.84. What is the ratio of the Aid flow (current US$) in South Asia in 2008 to that in 2009?
Your answer should be very brief. 2.28. What is the ratio of the Aid flow (current US$) in Upper middle income in 2008 to that in 2009?
Ensure brevity in your answer.  1.28. What is the ratio of the Aid flow (current US$) in Uganda in 2008 to that in 2009?
Your answer should be very brief. 1.01. What is the ratio of the Aid flow (current US$) of Small states in 2008 to that in 2010?
Give a very brief answer. 1.16. What is the ratio of the Aid flow (current US$) of South Asia in 2008 to that in 2010?
Provide a short and direct response. 3.38. What is the ratio of the Aid flow (current US$) in Upper middle income in 2008 to that in 2010?
Provide a short and direct response. 1.46. What is the ratio of the Aid flow (current US$) of Uganda in 2008 to that in 2010?
Keep it short and to the point. 1.04. What is the ratio of the Aid flow (current US$) in Small states in 2009 to that in 2010?
Your answer should be compact. 1.39. What is the ratio of the Aid flow (current US$) in South Asia in 2009 to that in 2010?
Your response must be concise. 1.48. What is the ratio of the Aid flow (current US$) in Upper middle income in 2009 to that in 2010?
Your answer should be compact. 1.14. What is the ratio of the Aid flow (current US$) of Uganda in 2009 to that in 2010?
Ensure brevity in your answer.  1.03. What is the difference between the highest and the second highest Aid flow (current US$) in Small states?
Your answer should be compact. 5.80e+05. What is the difference between the highest and the second highest Aid flow (current US$) of South Asia?
Your answer should be very brief. 2.01e+06. What is the difference between the highest and the second highest Aid flow (current US$) in Upper middle income?
Keep it short and to the point. 8.60e+05. What is the difference between the highest and the lowest Aid flow (current US$) in Small states?
Your response must be concise. 2.20e+06. What is the difference between the highest and the lowest Aid flow (current US$) in South Asia?
Keep it short and to the point. 6.84e+06. What is the difference between the highest and the lowest Aid flow (current US$) in Upper middle income?
Give a very brief answer. 1.66e+06. What is the difference between the highest and the lowest Aid flow (current US$) in Uganda?
Give a very brief answer. 1.59e+06. 